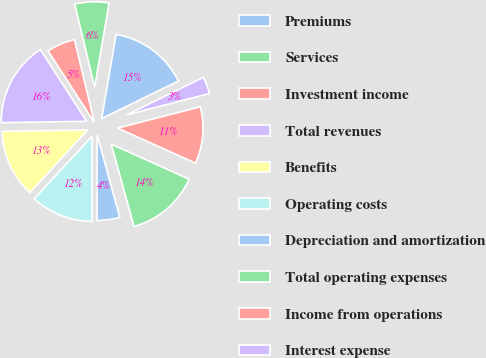Convert chart to OTSL. <chart><loc_0><loc_0><loc_500><loc_500><pie_chart><fcel>Premiums<fcel>Services<fcel>Investment income<fcel>Total revenues<fcel>Benefits<fcel>Operating costs<fcel>Depreciation and amortization<fcel>Total operating expenses<fcel>Income from operations<fcel>Interest expense<nl><fcel>15.05%<fcel>6.45%<fcel>5.38%<fcel>16.13%<fcel>12.9%<fcel>11.83%<fcel>4.3%<fcel>13.98%<fcel>10.75%<fcel>3.23%<nl></chart> 